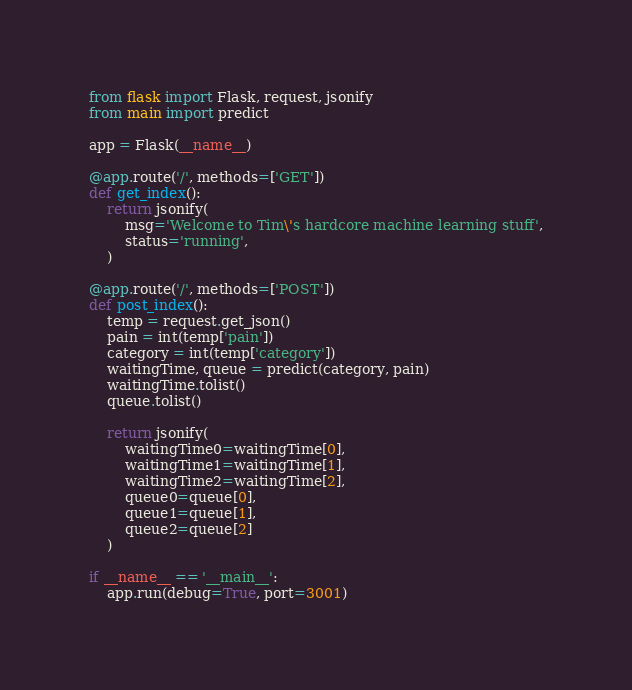<code> <loc_0><loc_0><loc_500><loc_500><_Python_>from flask import Flask, request, jsonify
from main import predict

app = Flask(__name__)

@app.route('/', methods=['GET'])
def get_index():
    return jsonify(
        msg='Welcome to Tim\'s hardcore machine learning stuff',
        status='running',
    )

@app.route('/', methods=['POST'])
def post_index():
    temp = request.get_json()
    pain = int(temp['pain'])
    category = int(temp['category'])
    waitingTime, queue = predict(category, pain)
    waitingTime.tolist()
    queue.tolist()

    return jsonify(
        waitingTime0=waitingTime[0],
        waitingTime1=waitingTime[1],
        waitingTime2=waitingTime[2],
        queue0=queue[0],
        queue1=queue[1],
        queue2=queue[2]
    )

if __name__ == '__main__':
    app.run(debug=True, port=3001)
</code> 